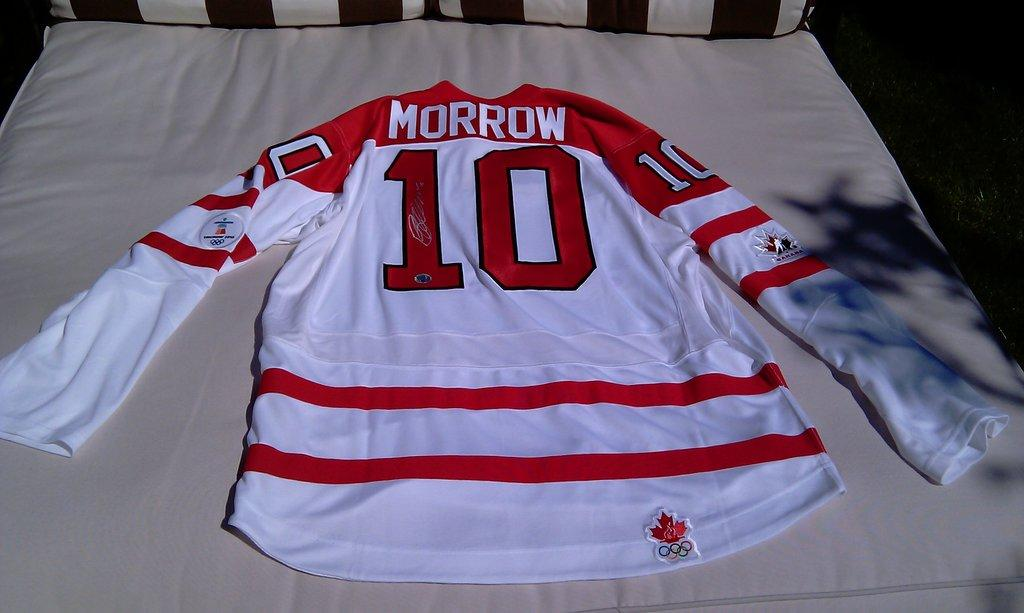<image>
Write a terse but informative summary of the picture. A Morrow number 10 jersey sits spread out on a bed with white covers. 